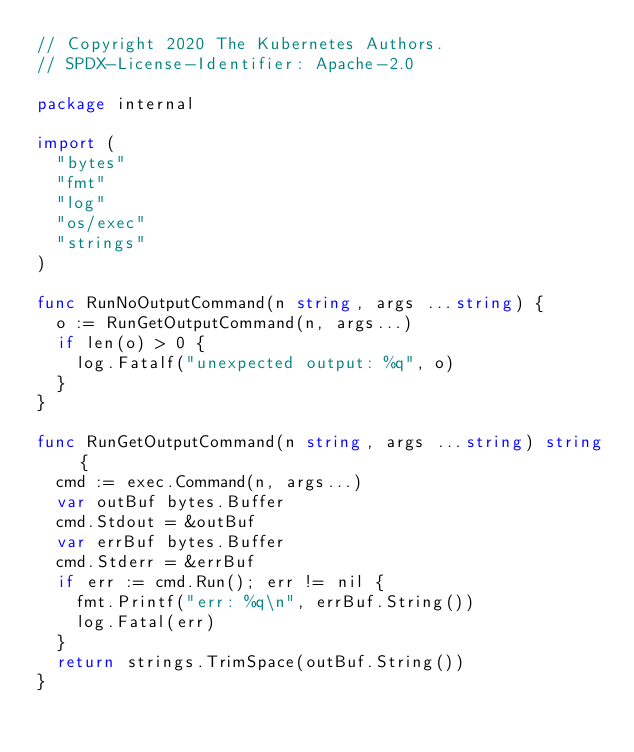Convert code to text. <code><loc_0><loc_0><loc_500><loc_500><_Go_>// Copyright 2020 The Kubernetes Authors.
// SPDX-License-Identifier: Apache-2.0

package internal

import (
	"bytes"
	"fmt"
	"log"
	"os/exec"
	"strings"
)

func RunNoOutputCommand(n string, args ...string) {
	o := RunGetOutputCommand(n, args...)
	if len(o) > 0 {
		log.Fatalf("unexpected output: %q", o)
	}
}

func RunGetOutputCommand(n string, args ...string) string {
	cmd := exec.Command(n, args...)
	var outBuf bytes.Buffer
	cmd.Stdout = &outBuf
	var errBuf bytes.Buffer
	cmd.Stderr = &errBuf
	if err := cmd.Run(); err != nil {
		fmt.Printf("err: %q\n", errBuf.String())
		log.Fatal(err)
	}
	return strings.TrimSpace(outBuf.String())
}
</code> 